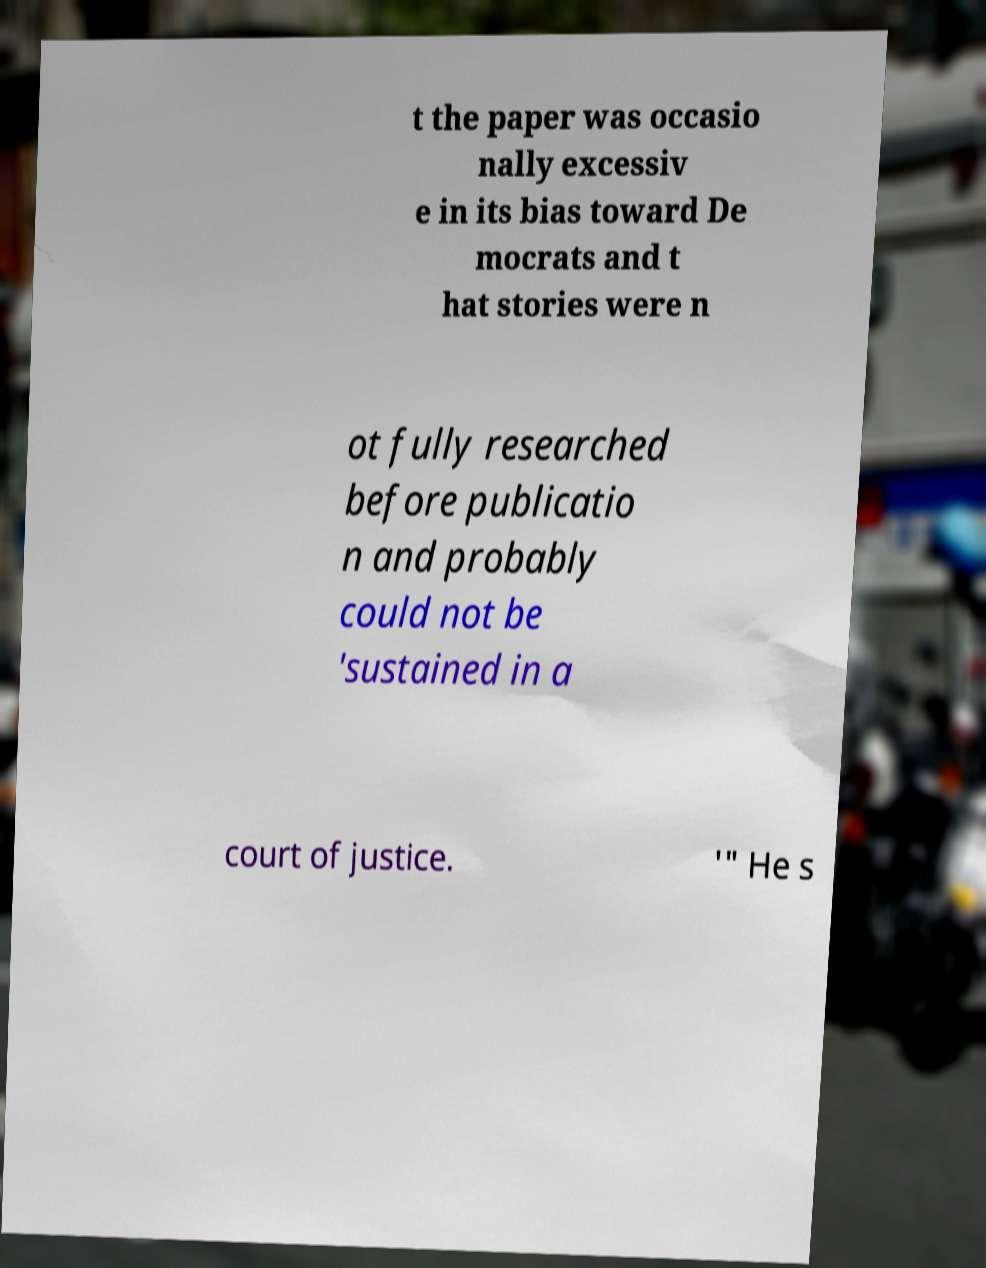Can you read and provide the text displayed in the image?This photo seems to have some interesting text. Can you extract and type it out for me? t the paper was occasio nally excessiv e in its bias toward De mocrats and t hat stories were n ot fully researched before publicatio n and probably could not be 'sustained in a court of justice. '" He s 